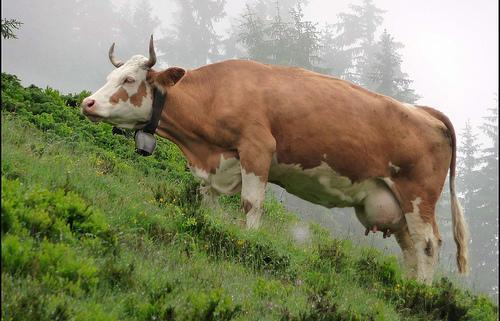How many ears can you see?
Give a very brief answer. 1. 